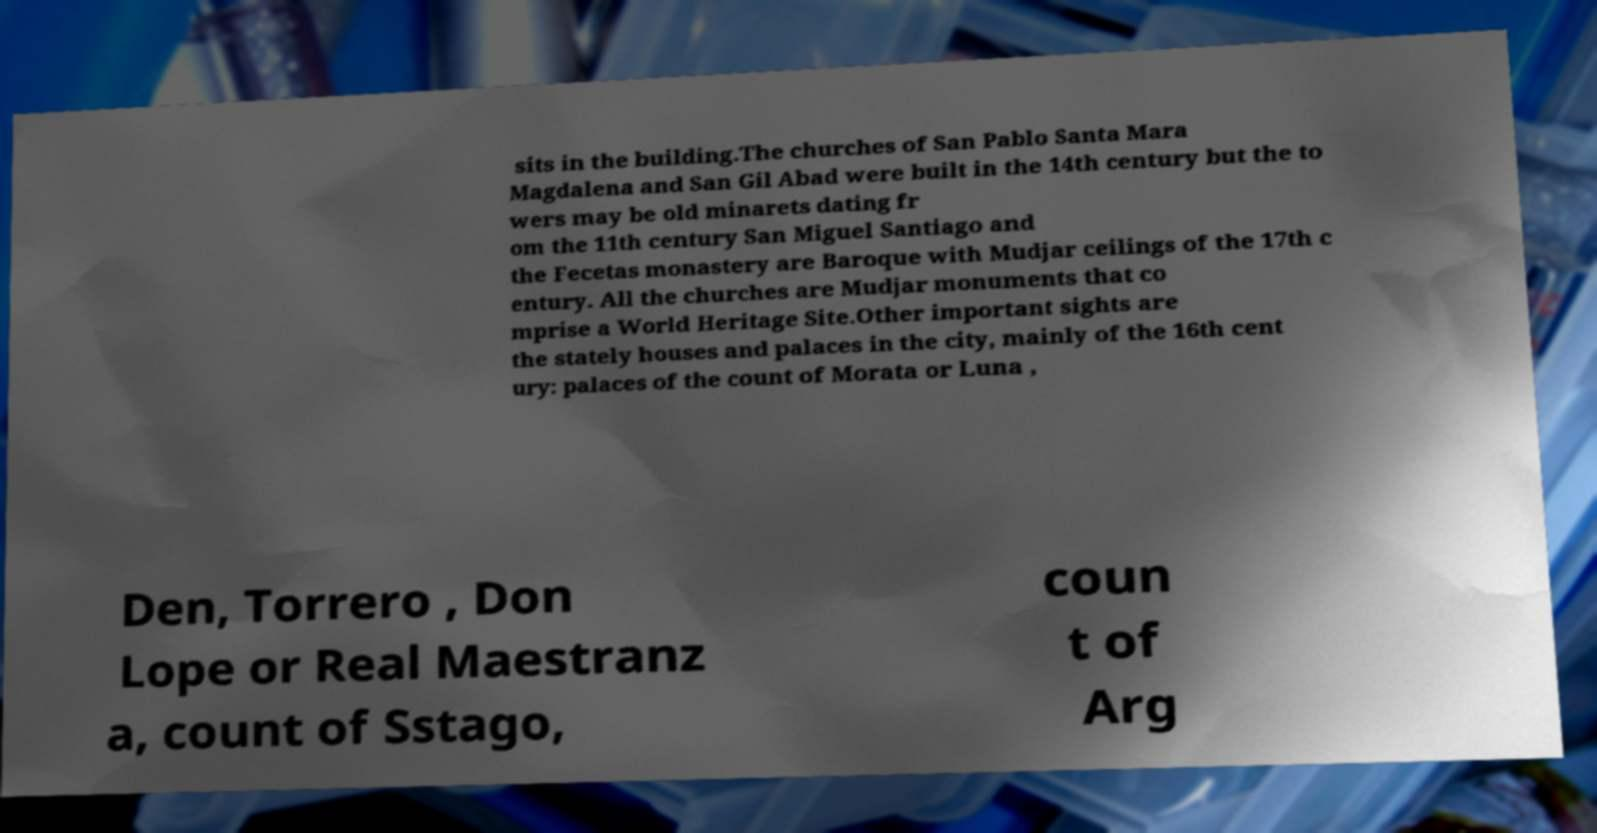For documentation purposes, I need the text within this image transcribed. Could you provide that? sits in the building.The churches of San Pablo Santa Mara Magdalena and San Gil Abad were built in the 14th century but the to wers may be old minarets dating fr om the 11th century San Miguel Santiago and the Fecetas monastery are Baroque with Mudjar ceilings of the 17th c entury. All the churches are Mudjar monuments that co mprise a World Heritage Site.Other important sights are the stately houses and palaces in the city, mainly of the 16th cent ury: palaces of the count of Morata or Luna , Den, Torrero , Don Lope or Real Maestranz a, count of Sstago, coun t of Arg 